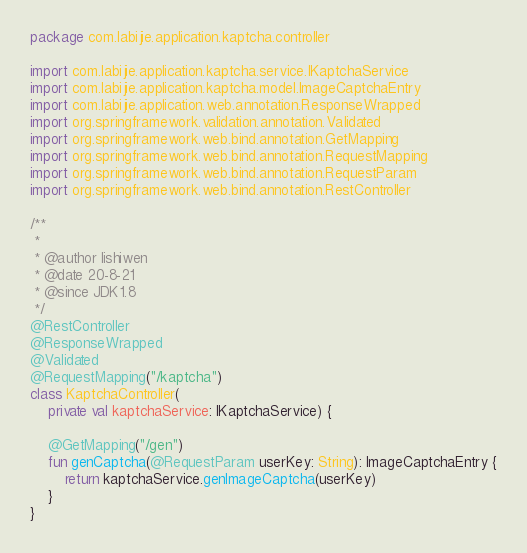<code> <loc_0><loc_0><loc_500><loc_500><_Kotlin_>package com.labijie.application.kaptcha.controller

import com.labijie.application.kaptcha.service.IKaptchaService
import com.labijie.application.kaptcha.model.ImageCaptchaEntry
import com.labijie.application.web.annotation.ResponseWrapped
import org.springframework.validation.annotation.Validated
import org.springframework.web.bind.annotation.GetMapping
import org.springframework.web.bind.annotation.RequestMapping
import org.springframework.web.bind.annotation.RequestParam
import org.springframework.web.bind.annotation.RestController

/**
 *
 * @author lishiwen
 * @date 20-8-21
 * @since JDK1.8
 */
@RestController
@ResponseWrapped
@Validated
@RequestMapping("/kaptcha")
class KaptchaController(
    private val kaptchaService: IKaptchaService) {

    @GetMapping("/gen")
    fun genCaptcha(@RequestParam userKey: String): ImageCaptchaEntry {
        return kaptchaService.genImageCaptcha(userKey)
    }
}</code> 